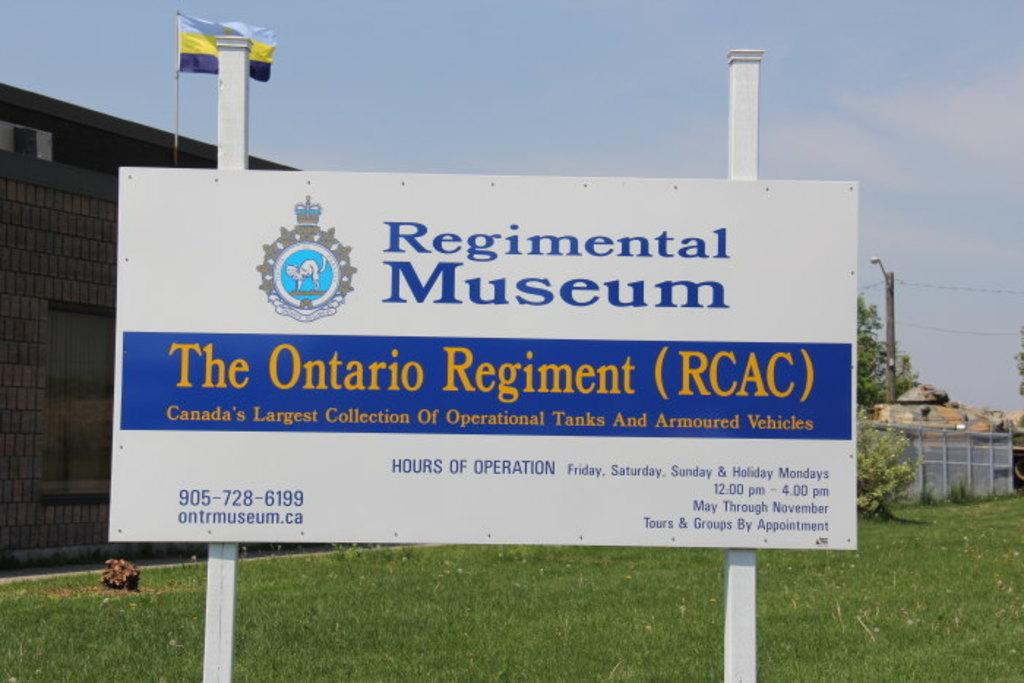<image>
Offer a succinct explanation of the picture presented. sign on lawn for Regimental Museum The Ontario Regiment 